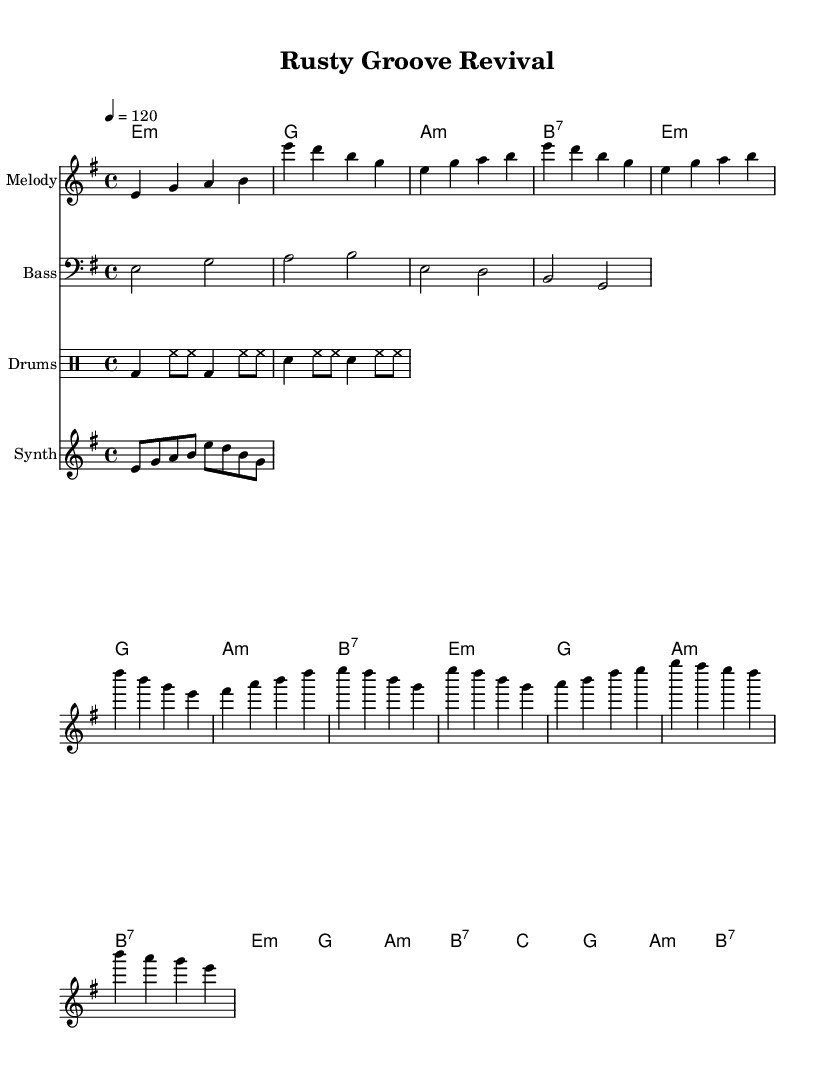What is the key signature of this music? The key signature is E minor, which contains one sharp (F#) and indicates that the piece is in a minor tonality.
Answer: E minor What is the time signature of this music? The time signature is 4/4, which means there are four beats in each measure and a quarter note gets one beat.
Answer: 4/4 What is the tempo marking for this piece? The tempo marking is given as 120 beats per minute, specified in the code. This setting determines the speed at which the piece should be played.
Answer: 120 How many measures are in the chorus section? The chorus section consists of 8 measures as counted from the score; this is identified by examining the repeated rhythmic and melodic patterns.
Answer: 8 What type of synth voice is indicated in the score? The synth is assumed to be a lead instrument due to its melodic line marked in a separate staff, typical for energetic disco music highlighting funky riffs.
Answer: Synth In which part of the music does the bass line first appear? The bass line first appears at the beginning of the score right after the introduction, providing a foundational groove that supports the overall disco feel.
Answer: Intro Which rhythmic pattern is used predominantly in the drum section? The predominant rhythmic pattern in the drum section consists of a bass drum and snare hits alternating with hi-hats, a common technique in disco music to create a danceable groove.
Answer: Bass and snare with hi-hats 